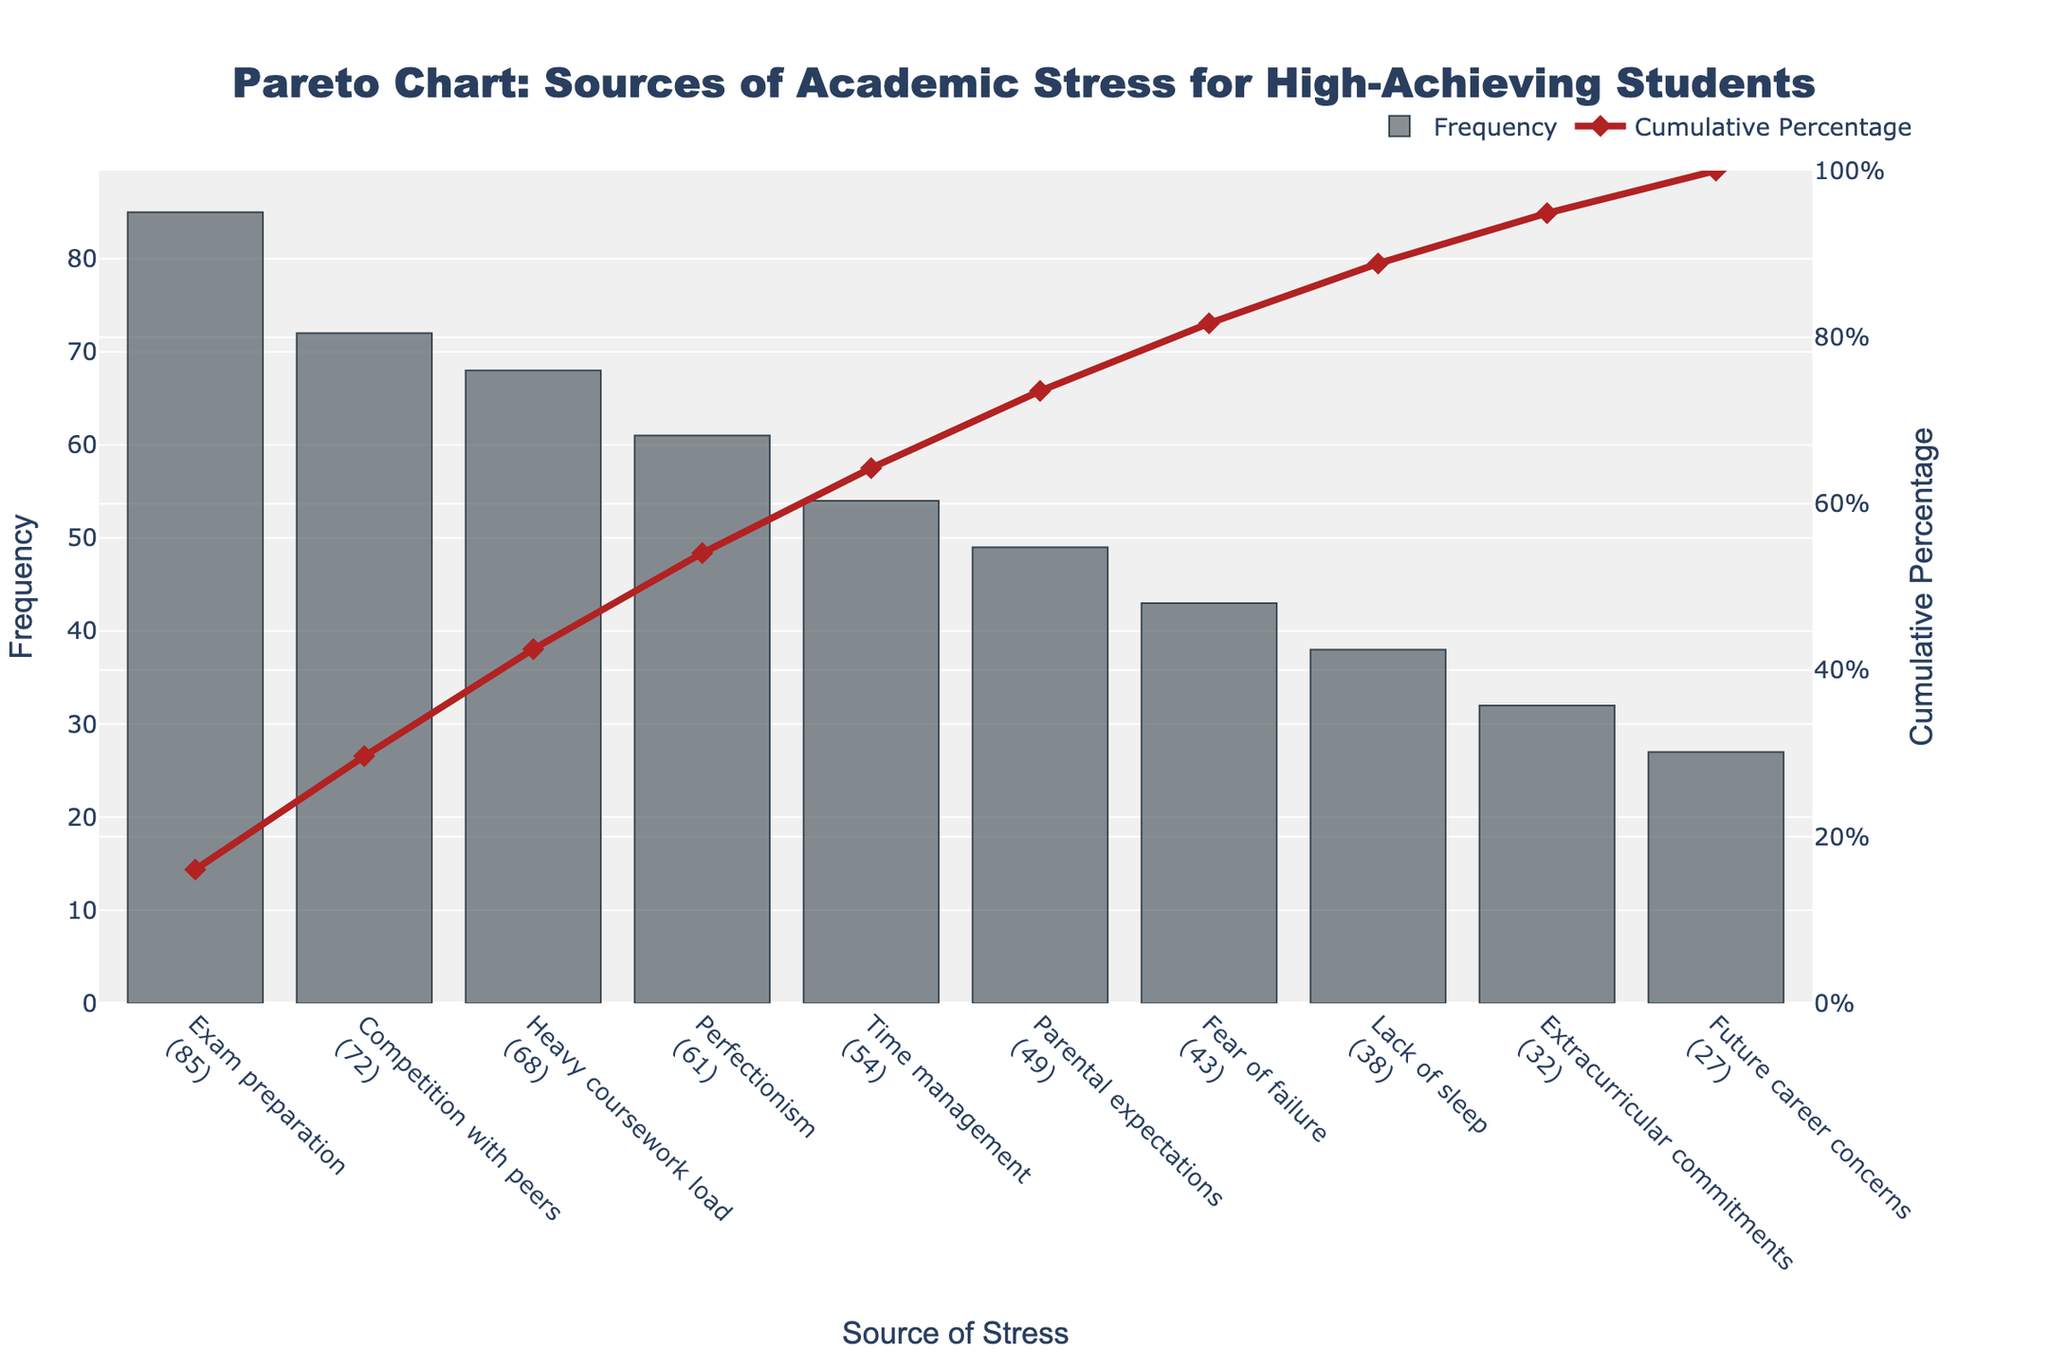What is the title of the chart? The title is displayed prominently at the top of the chart and is centered. It reads "Pareto Chart: Sources of Academic Stress for High-Achieving Students".
Answer: Pareto Chart: Sources of Academic Stress for High-Achieving Students What is the source with the highest frequency? The source at the far left of the bar chart has the highest frequency, which is "Exam preparation" with a frequency of 85.
Answer: Exam preparation Which source of stress has a cumulative percentage just above 50%? To find the source with a cumulative percentage just above 50%, we look at the line chart and find that “Perfectionism” has a cumulative percentage of approximately 51% based on the visual inspection.
Answer: Perfectionism How many sources have a frequency greater than 50? By counting the bars with a frequency greater than 50, we see that there are five sources: Exam preparation, Competition with peers, Heavy coursework load, Perfectionism, and Time management.
Answer: 5 What is the difference in frequency between "Competition with peers" and "Extracurricular commitments"? The frequency of "Competition with peers" is 72 and for "Extracurricular commitments" is 32. The difference is 72 - 32, which equals 40.
Answer: 40 Which sources contribute to reaching a cumulative percentage of exactly or close to 90%? Exam preparation, Competition with peers, Heavy coursework load, Perfectionism, Time management, and Parental expectations together contribute to reaching around 90%. We sum their cumulative percentages to verify: 85+72+68+61+54+49 = 389/499 * 100 ≈ 90%.
Answer: Exam preparation, Competition with peers, Heavy coursework load, Perfectionism, Time management, Parental expectations How does the cumulative percentage change between "Fear of failure" and "Lack of sleep"? The cumulative percentage at “Fear of failure” is slightly above 80% and at “Lack of sleep” is roughly 88%. Therefore, the change is about 88% - 80% = 8%.
Answer: 8% What can you deduce about the relative importance of the sources listed at the tail end of the chart? Sources like "Extracurricular commitments" and "Future career concerns" have significantly lower frequencies and their contributions to the cumulative percentage curve are minimal. This suggests they are less prominent sources of stress for high-achieving students.
Answer: Less prominent 